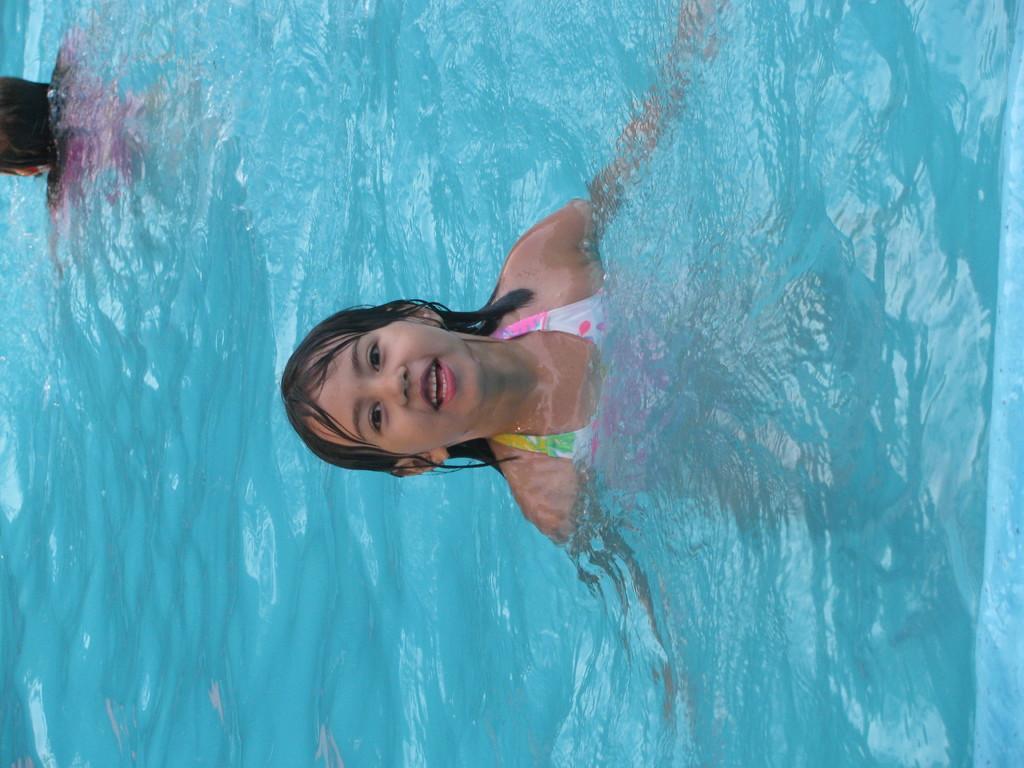In one or two sentences, can you explain what this image depicts? In this image we can see a person in the water. On the left side of the image there is an another person in the water. 